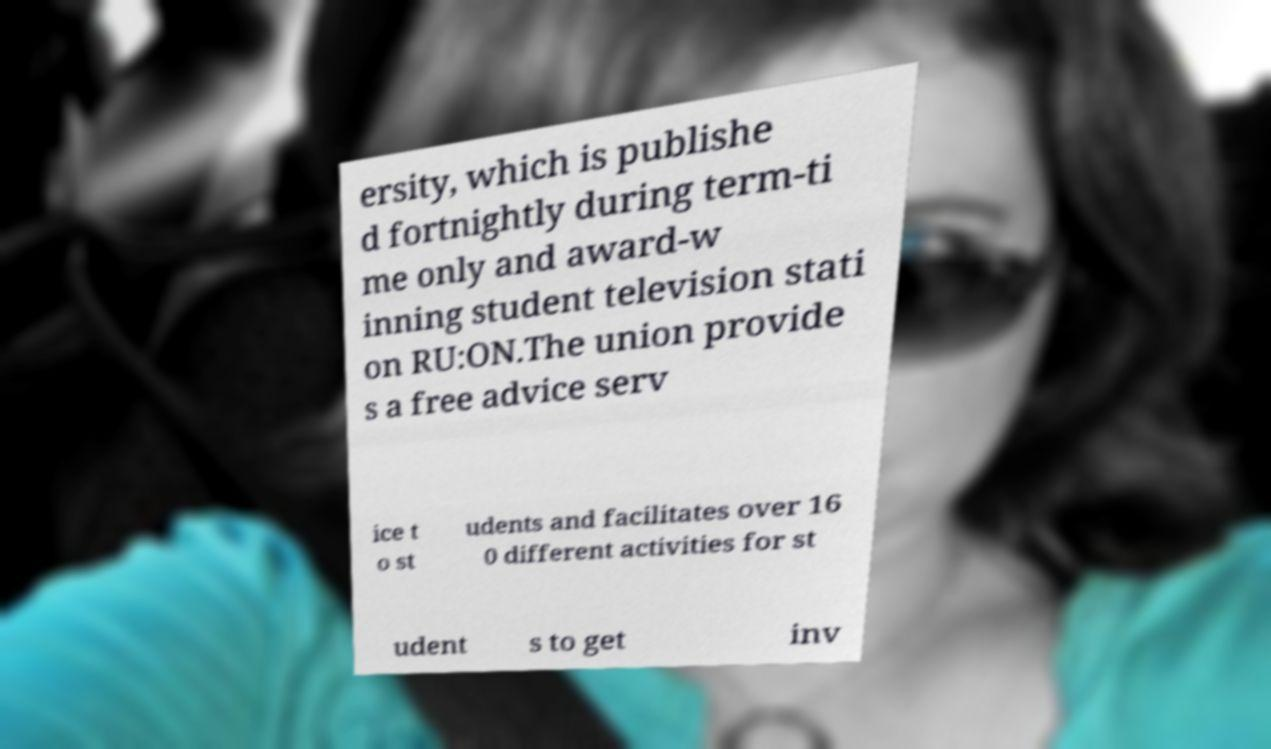Could you assist in decoding the text presented in this image and type it out clearly? ersity, which is publishe d fortnightly during term-ti me only and award-w inning student television stati on RU:ON.The union provide s a free advice serv ice t o st udents and facilitates over 16 0 different activities for st udent s to get inv 